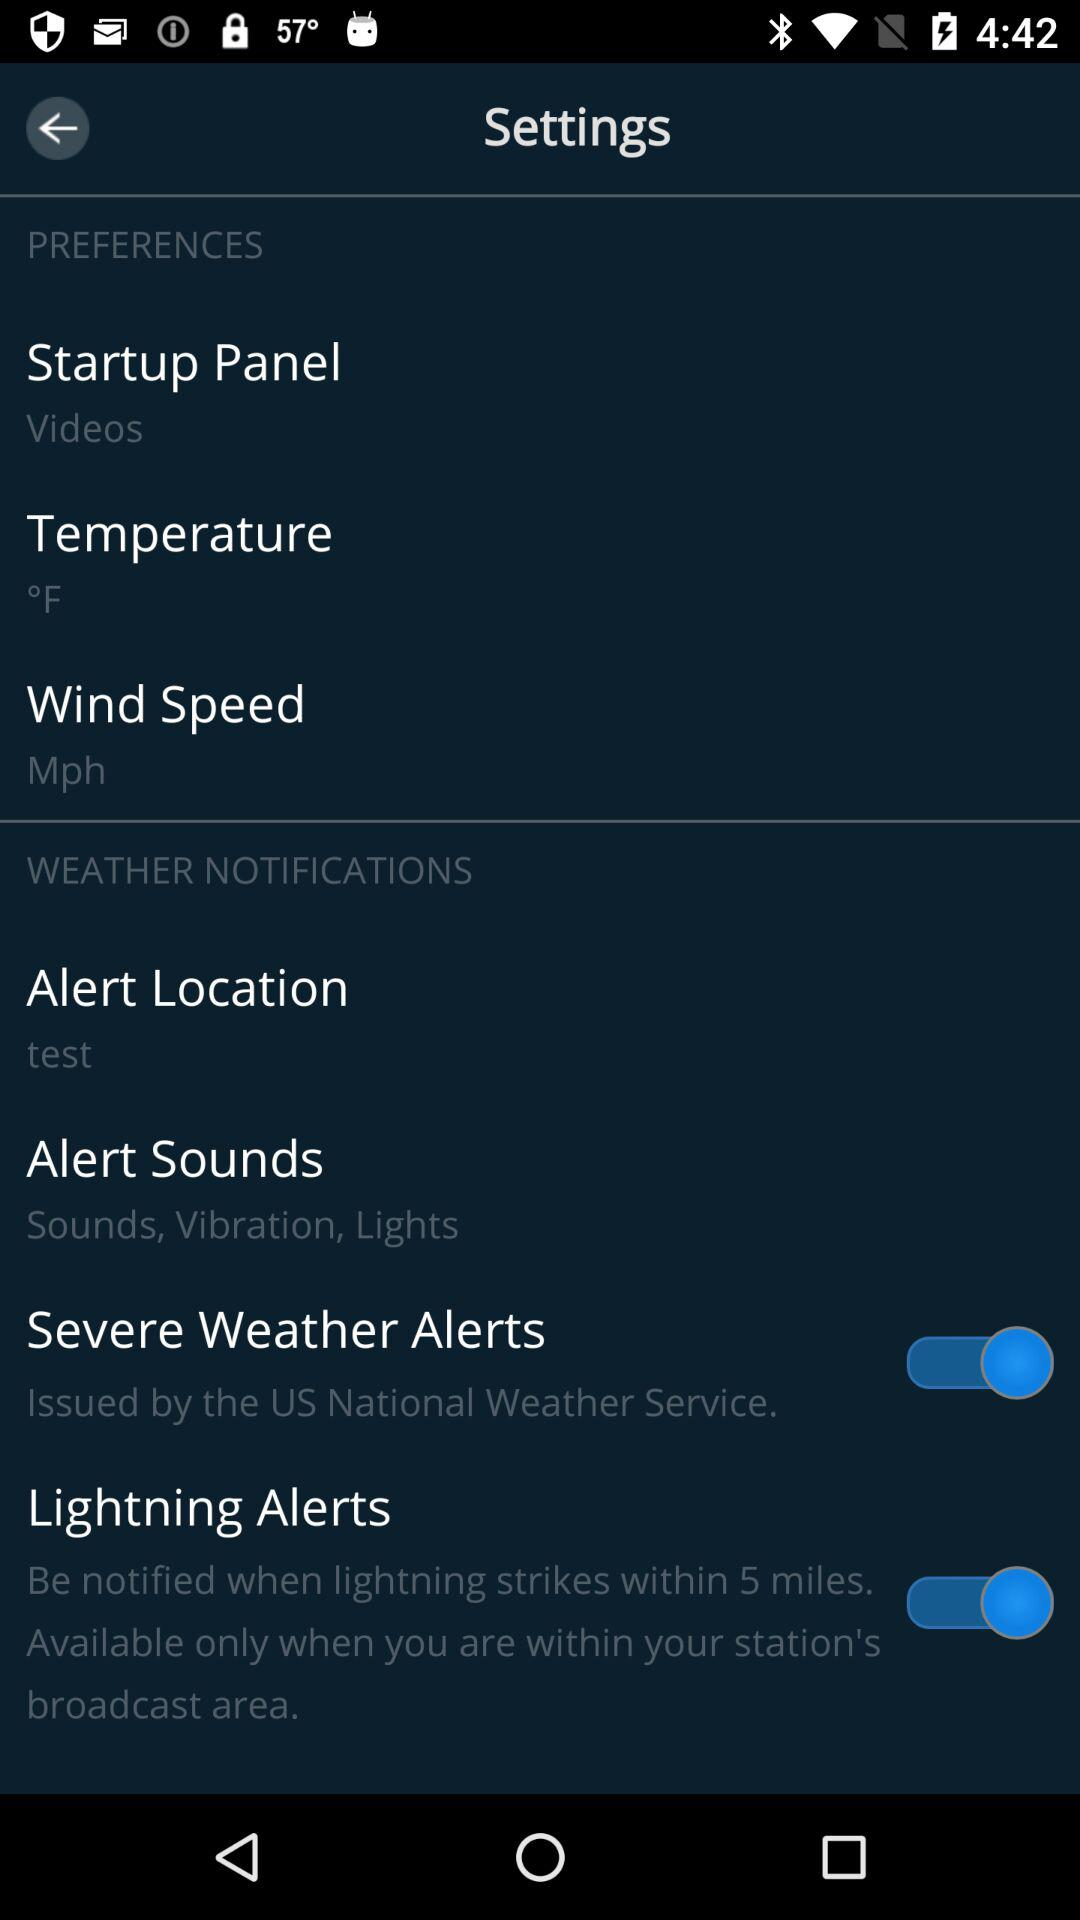What is the status of "Lightning Alerts"? The status is "on". 